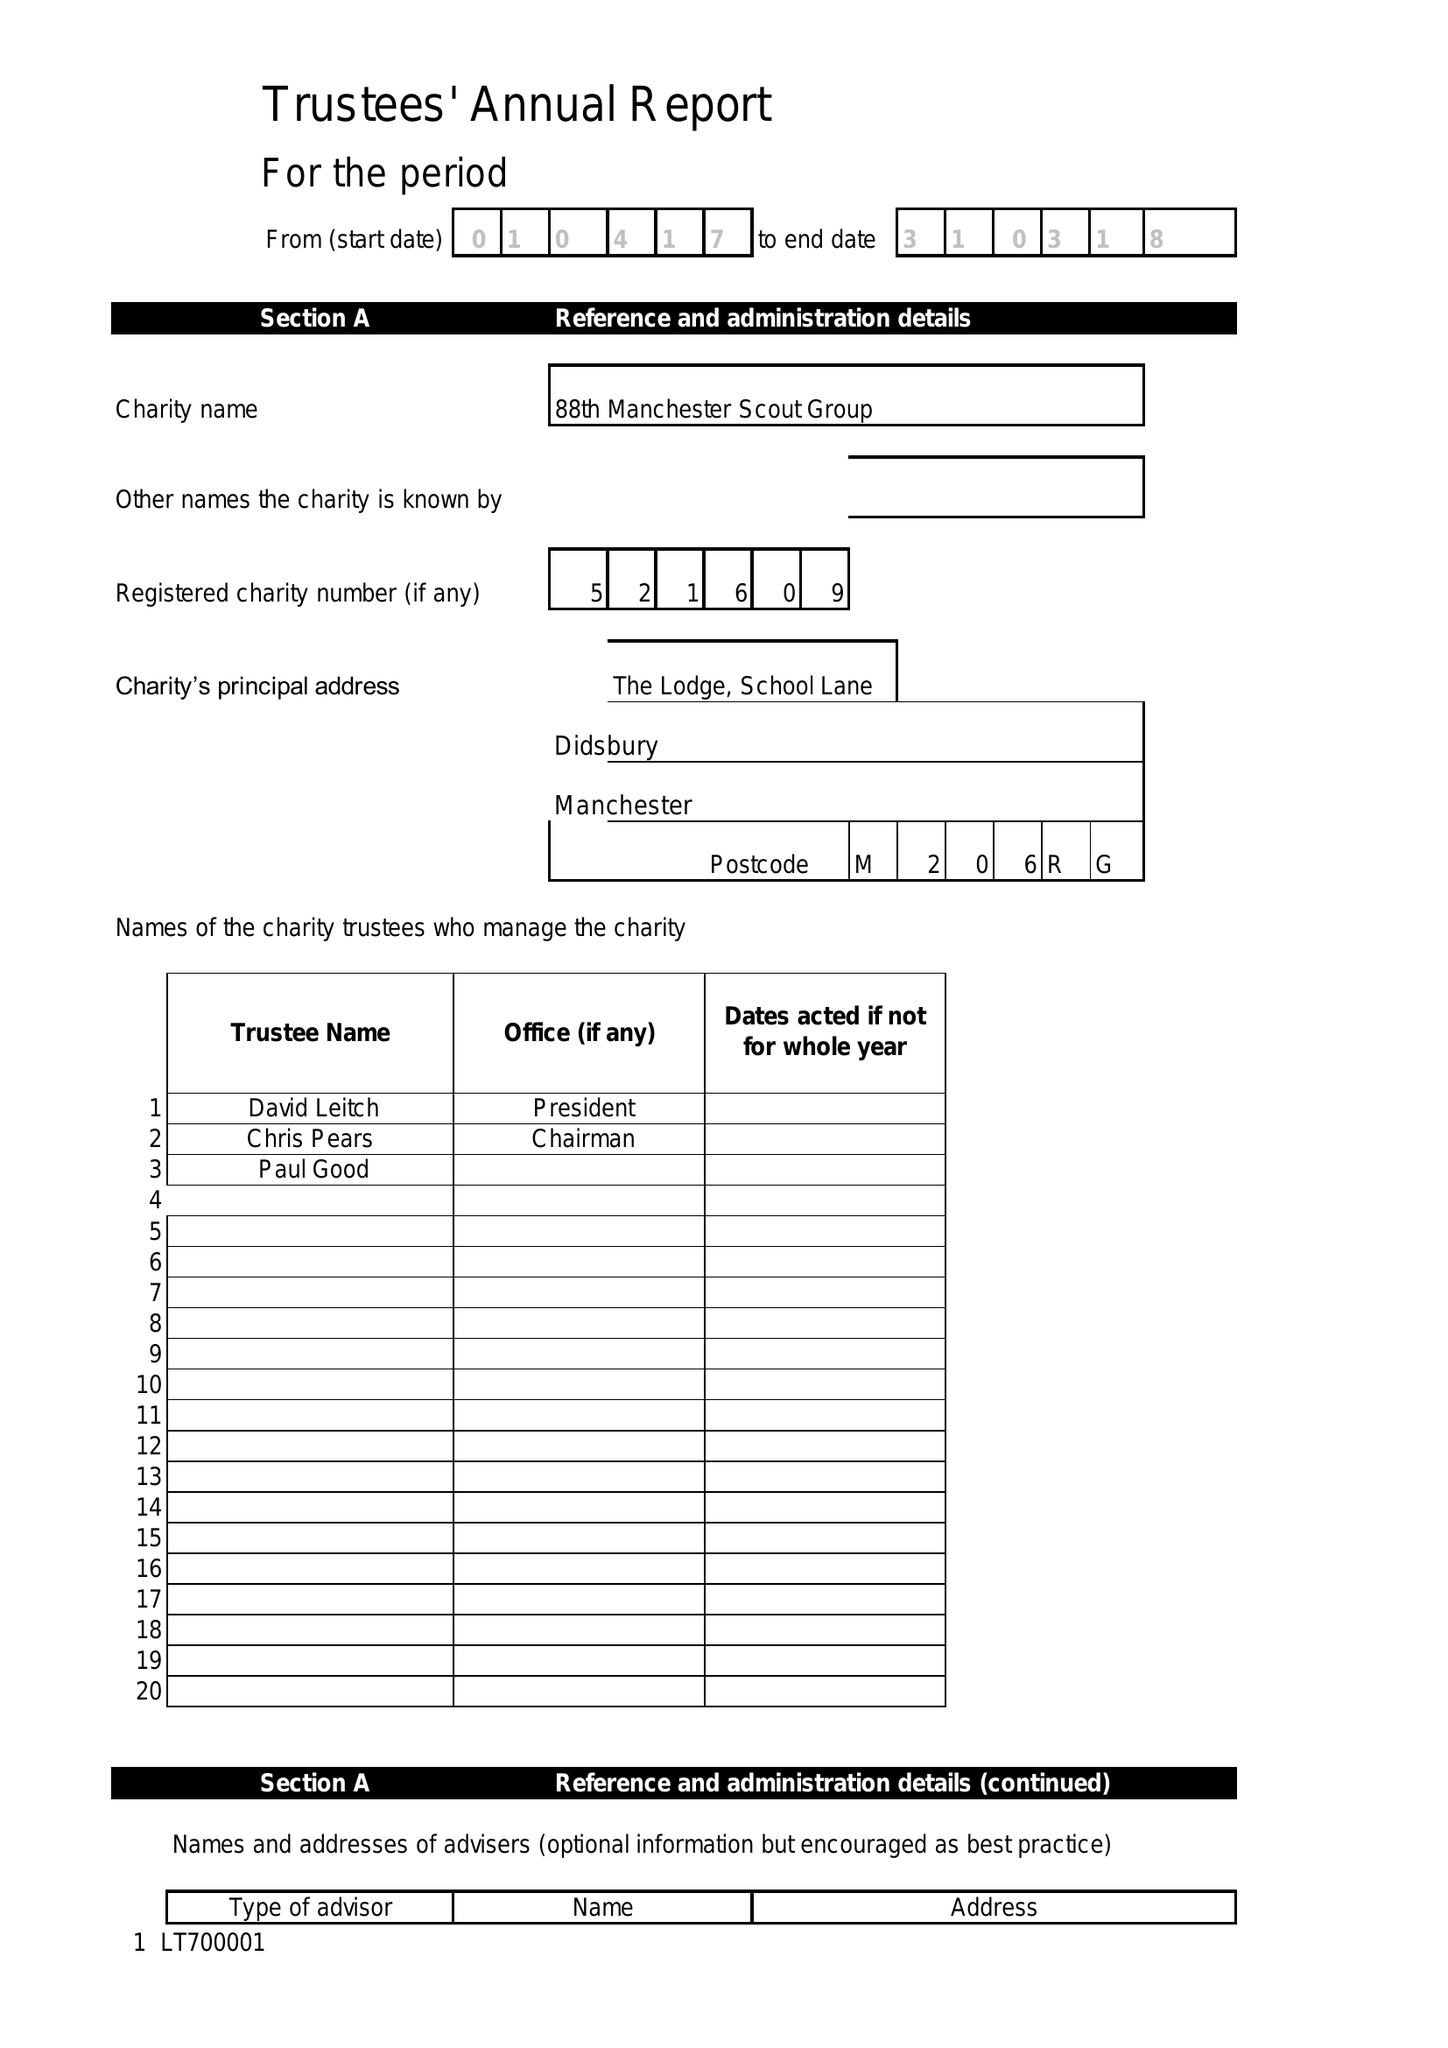What is the value for the charity_name?
Answer the question using a single word or phrase. 2/88 Manchester Scout Group 